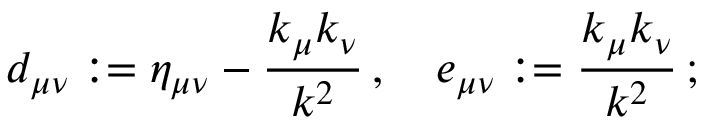<formula> <loc_0><loc_0><loc_500><loc_500>d _ { \mu \nu } \colon = \eta _ { \mu \nu } - \frac { k _ { \mu } k _ { \nu } } { k ^ { 2 } } \, , \quad e _ { \mu \nu } \colon = \frac { k _ { \mu } k _ { \nu } } { k ^ { 2 } } \, ;</formula> 